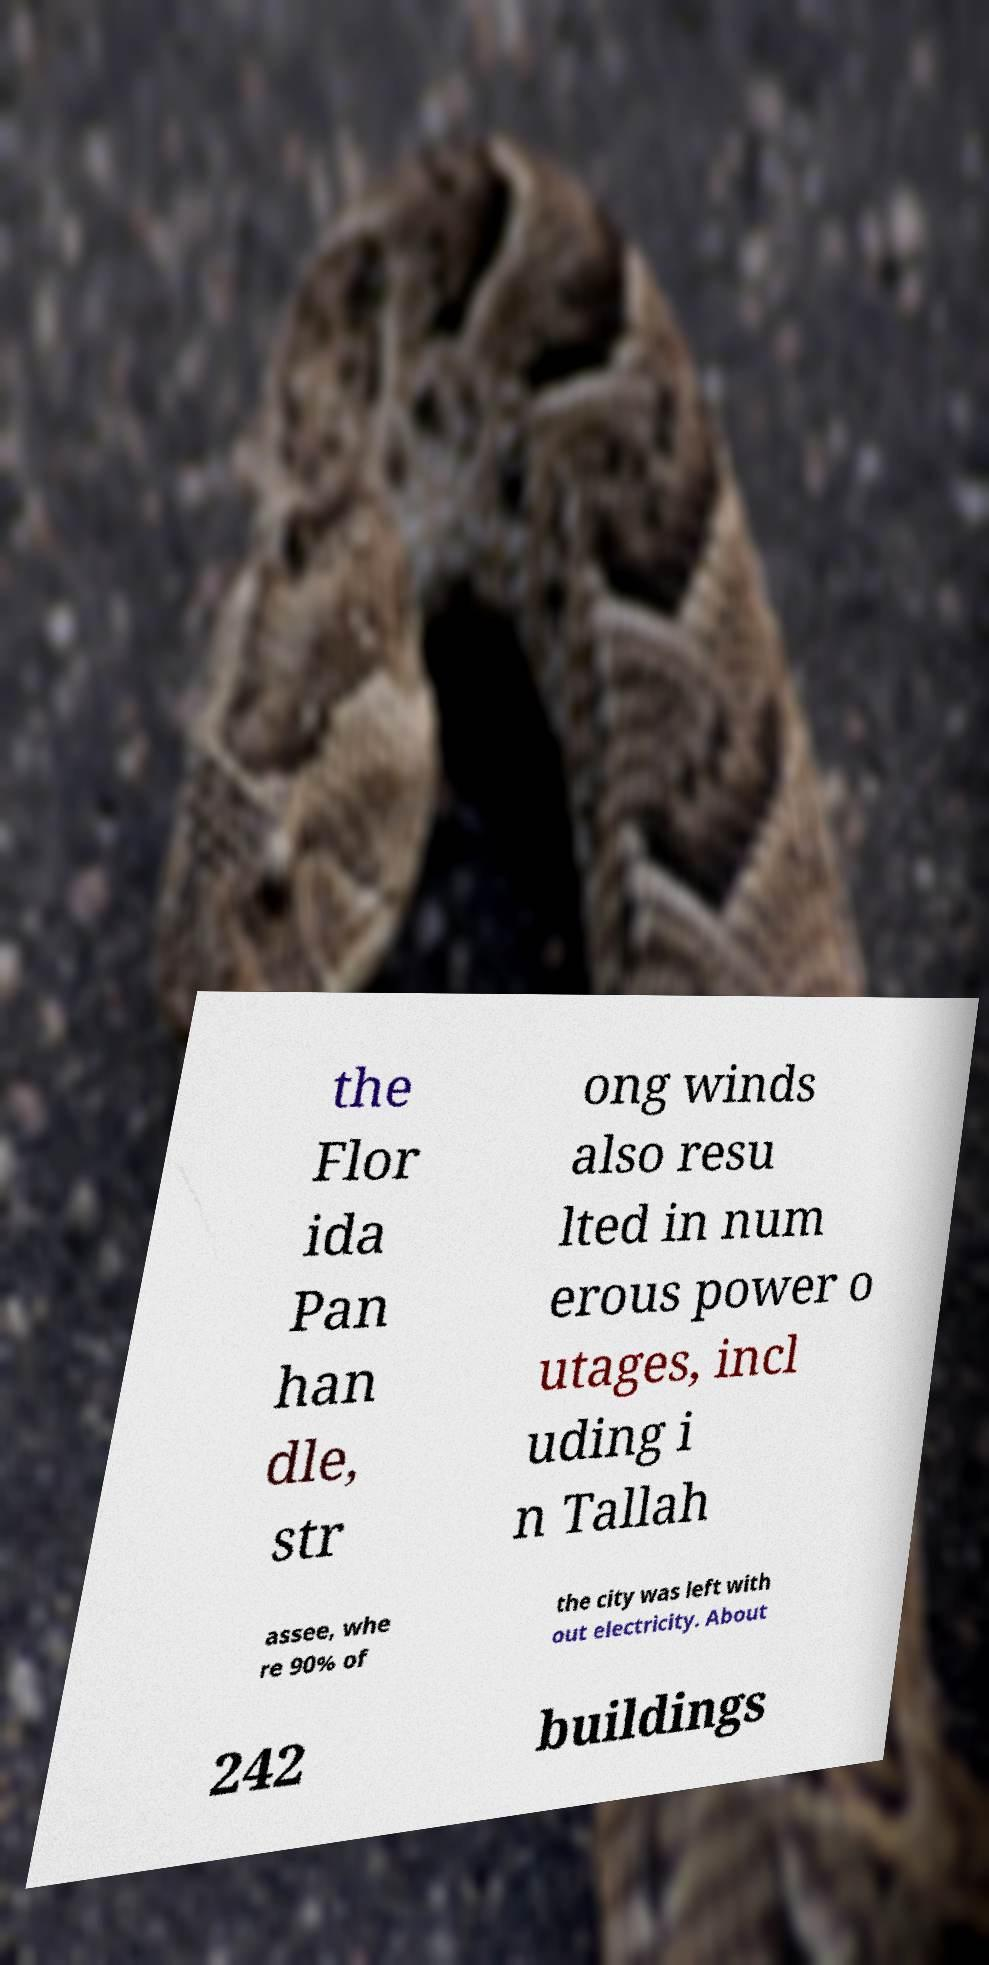Please read and relay the text visible in this image. What does it say? the Flor ida Pan han dle, str ong winds also resu lted in num erous power o utages, incl uding i n Tallah assee, whe re 90% of the city was left with out electricity. About 242 buildings 